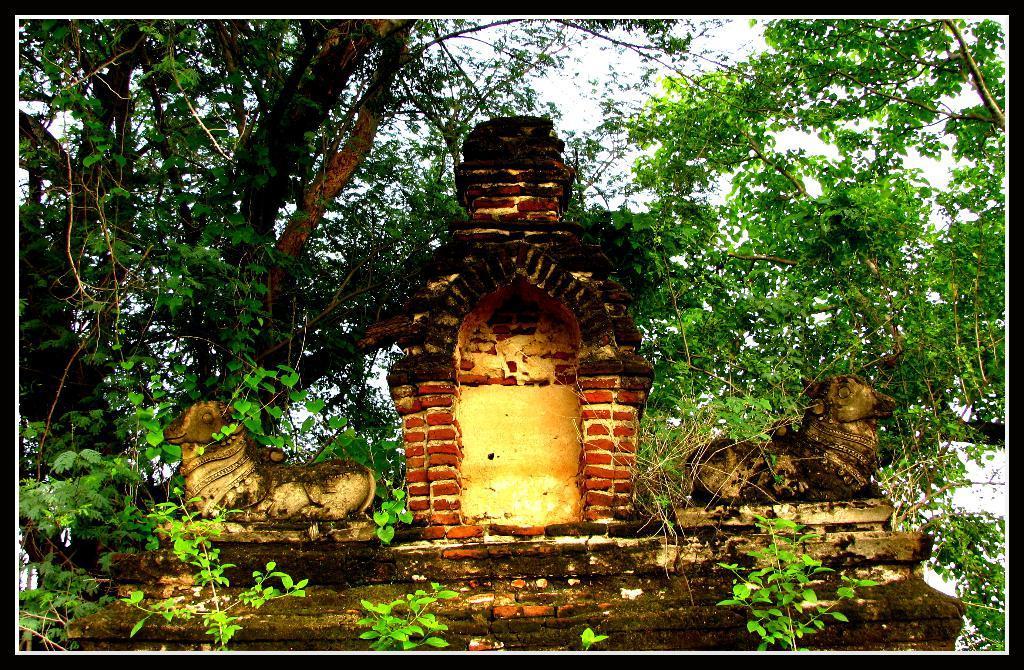Could you give a brief overview of what you see in this image? In this picture I can see a wall in the middle, there are statues on the either side of this image, in the background there are trees, at the top I can see the sky. 